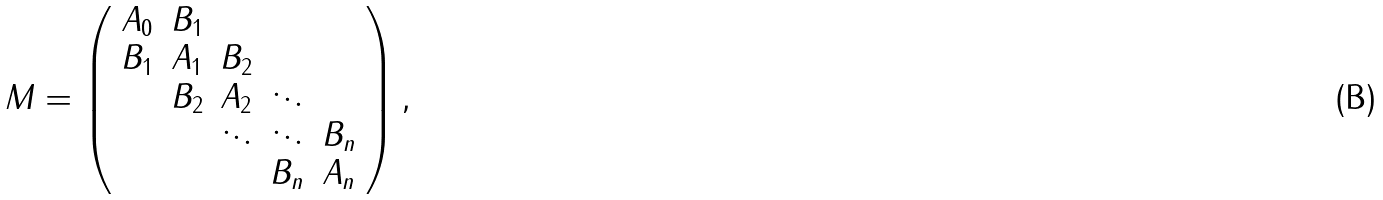<formula> <loc_0><loc_0><loc_500><loc_500>M = \left ( \begin{array} { c c c c c } A _ { 0 } & B _ { 1 } \\ B _ { 1 } & A _ { 1 } & B _ { 2 } \\ & B _ { 2 } & A _ { 2 } & \ddots \\ & & \ddots & \ddots & B _ { n } \\ & & & B _ { n } & A _ { n } \end{array} \right ) ,</formula> 